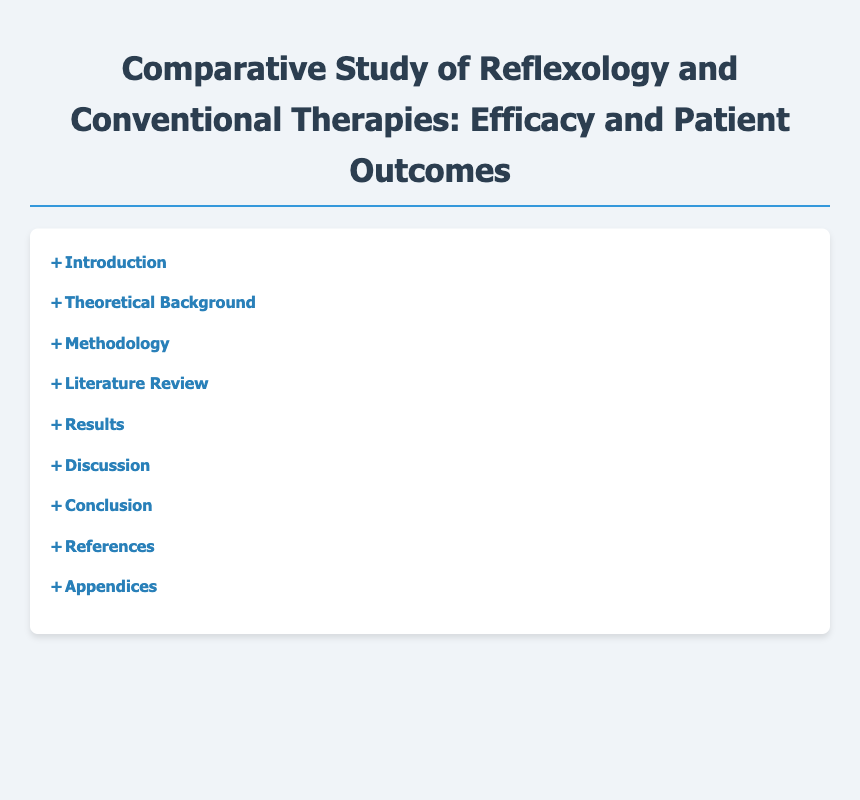What is the title of the document? The title of the document appears at the top of the rendered content, which is "Comparative Study of Reflexology and Conventional Therapies: Efficacy and Patient Outcomes."
Answer: Comparative Study of Reflexology and Conventional Therapies: Efficacy and Patient Outcomes How many main sections are in the Table of Contents? The number of main sections can be counted by observing the distinct categories listed in the Table of Contents. There are seven main sections.
Answer: 7 What is the first subsection under the "Introduction"? The first subsection is listed under the "Introduction" section and provides an overview topic.
Answer: Overview of Reflexology What does the "Results" section primarily compare? The "Results" section outlines the comparisons made between Reflexology and Conventional Therapies.
Answer: Patient Outcomes: Reflexology vs Conventional Therapies Which section discusses the psychological effects related to Reflexology? The section specifically addressing this topic is noted clearly in the structure of the document.
Answer: Psychological Effects of Reflexology What is one of the recommendations mentioned in the "Conclusion"? The "Conclusion" section mentions future research recommendations, which are specific suggestions for the field.
Answer: Recommendations for Further Research In which section would you find the citation sources? The section that typically contains the references or citation sources of the document is noted clearly.
Answer: References What is the title of the last section of the document? The last section of the document typically concludes the information provided and is clearly labeled.
Answer: Appendices 